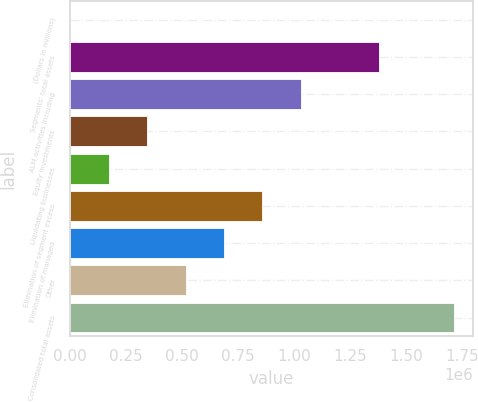<chart> <loc_0><loc_0><loc_500><loc_500><bar_chart><fcel>(Dollars in millions)<fcel>Segments' total assets<fcel>ALM activities including<fcel>Equity investments<fcel>Liquidating businesses<fcel>Elimination of segment excess<fcel>Elimination of managed<fcel>Other<fcel>Consolidated total assets<nl><fcel>2007<fcel>1.37916e+06<fcel>1.03025e+06<fcel>344755<fcel>173381<fcel>858876<fcel>687503<fcel>516129<fcel>1.71575e+06<nl></chart> 